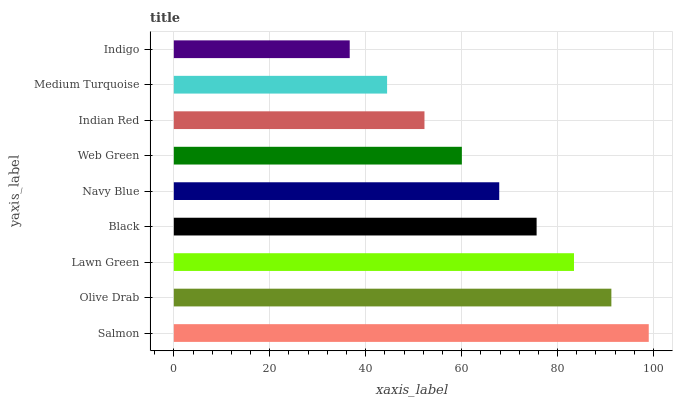Is Indigo the minimum?
Answer yes or no. Yes. Is Salmon the maximum?
Answer yes or no. Yes. Is Olive Drab the minimum?
Answer yes or no. No. Is Olive Drab the maximum?
Answer yes or no. No. Is Salmon greater than Olive Drab?
Answer yes or no. Yes. Is Olive Drab less than Salmon?
Answer yes or no. Yes. Is Olive Drab greater than Salmon?
Answer yes or no. No. Is Salmon less than Olive Drab?
Answer yes or no. No. Is Navy Blue the high median?
Answer yes or no. Yes. Is Navy Blue the low median?
Answer yes or no. Yes. Is Olive Drab the high median?
Answer yes or no. No. Is Indigo the low median?
Answer yes or no. No. 